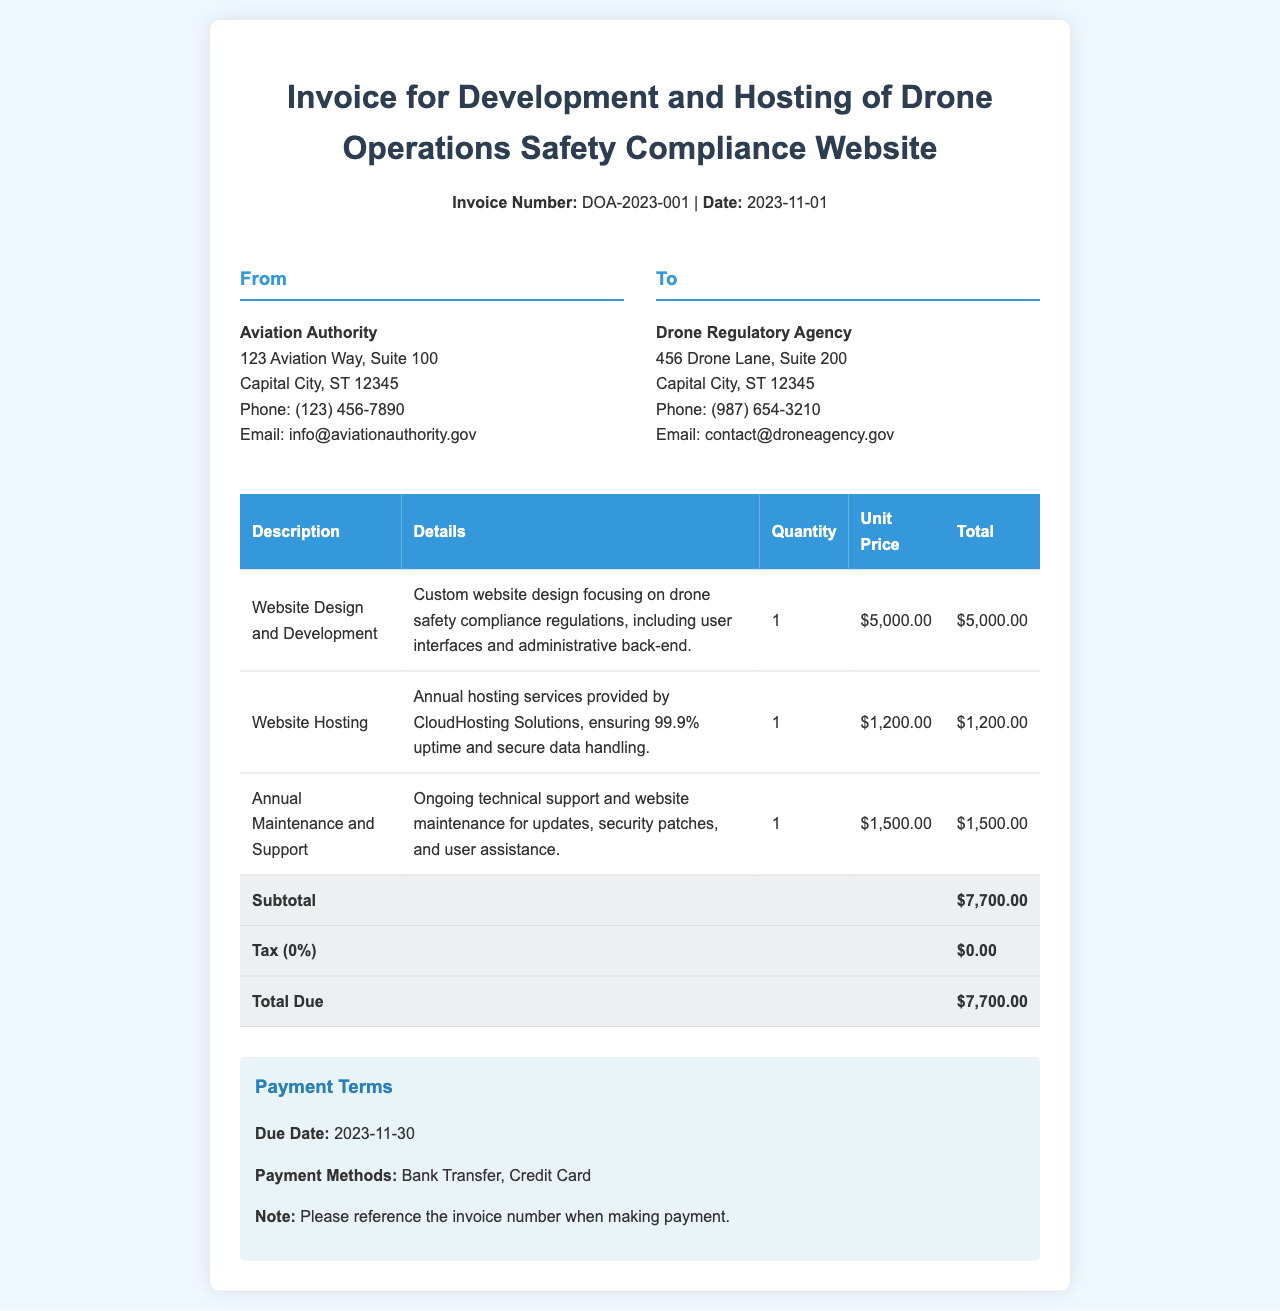What is the invoice number? The invoice number is specified in the header section of the document.
Answer: DOA-2023-001 What is the total due amount? The total due amount is calculated and presented in the totals section of the invoice.
Answer: $7,700.00 Who is the sender of the invoice? The sender's information is provided in the "From" section of the document.
Answer: Aviation Authority What services are included in the invoice? The services are detailed in the itemized charges in the invoice table.
Answer: Website Design and Development, Website Hosting, Annual Maintenance and Support What is the due date for the payment? The due date is clearly stated in the payment terms section of the document.
Answer: 2023-11-30 How much is charged for website hosting? The cost for website hosting is listed in the invoice table under itemized charges.
Answer: $1,200.00 What is the quantity for Annual Maintenance and Support? The quantity is mentioned in the invoice table corresponding to the respective service.
Answer: 1 What is the subtotal before tax? The subtotal is calculated from the itemized charges before applying any tax.
Answer: $7,700.00 What payment methods are accepted? Payment methods are listed in the payment terms section of the document.
Answer: Bank Transfer, Credit Card 